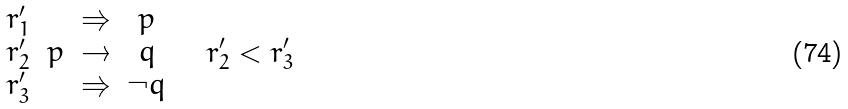<formula> <loc_0><loc_0><loc_500><loc_500>\begin{array} [ t ] { r c r c l } r ^ { \prime } _ { 1 } & & \Rightarrow & p \\ r ^ { \prime } _ { 2 } & p & \rightarrow & q \\ r ^ { \prime } _ { 3 } & & \Rightarrow & \neg q \end{array} \quad r ^ { \prime } _ { 2 } < r ^ { \prime } _ { 3 }</formula> 